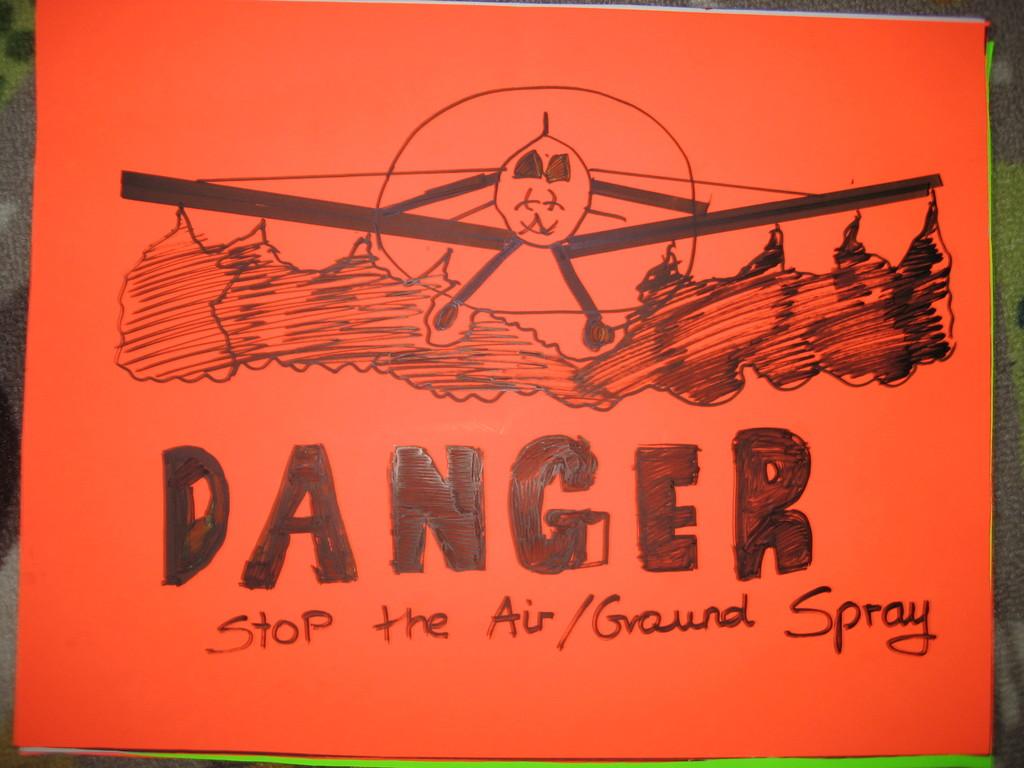What is the big letter word at the top of the words?
Ensure brevity in your answer.  Danger. Stop the what kind of spray?
Give a very brief answer. Air/ground. 